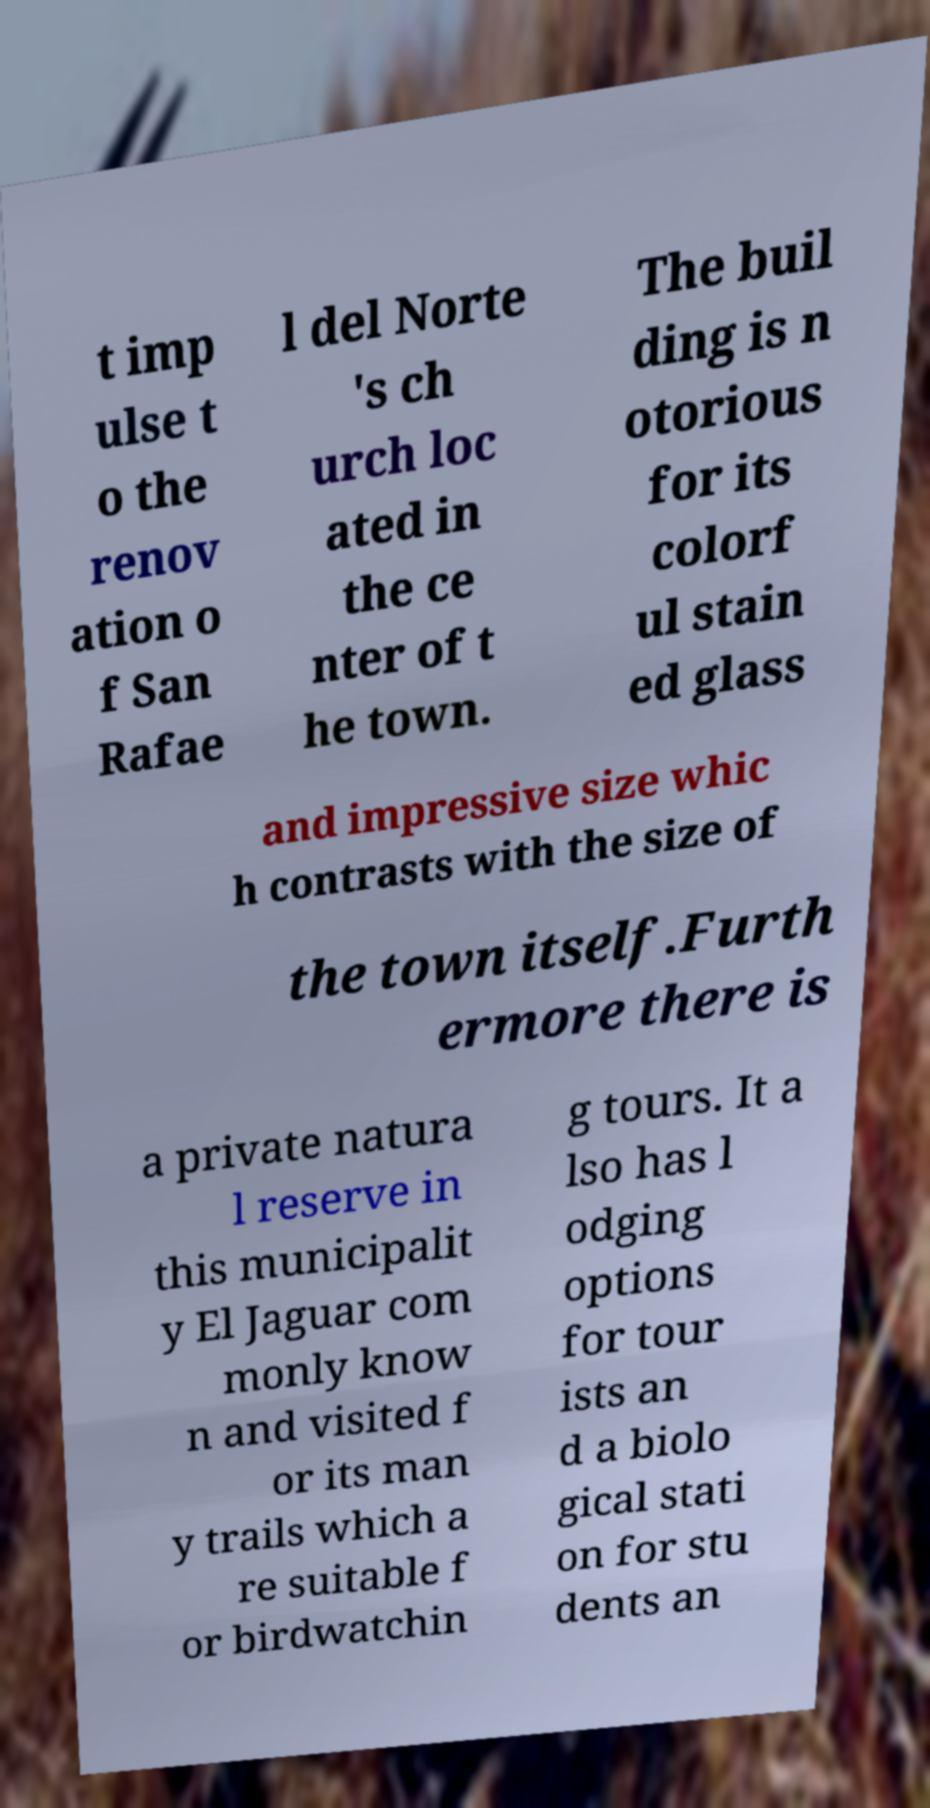There's text embedded in this image that I need extracted. Can you transcribe it verbatim? t imp ulse t o the renov ation o f San Rafae l del Norte 's ch urch loc ated in the ce nter of t he town. The buil ding is n otorious for its colorf ul stain ed glass and impressive size whic h contrasts with the size of the town itself.Furth ermore there is a private natura l reserve in this municipalit y El Jaguar com monly know n and visited f or its man y trails which a re suitable f or birdwatchin g tours. It a lso has l odging options for tour ists an d a biolo gical stati on for stu dents an 